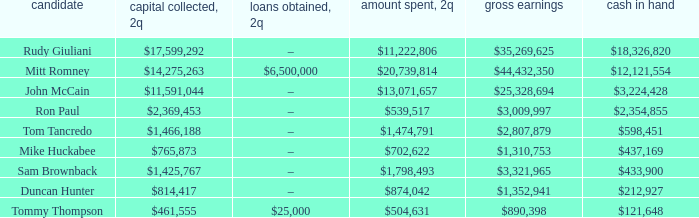Tell me the money raised when 2Q has total receipts of $890,398 $461,555. 